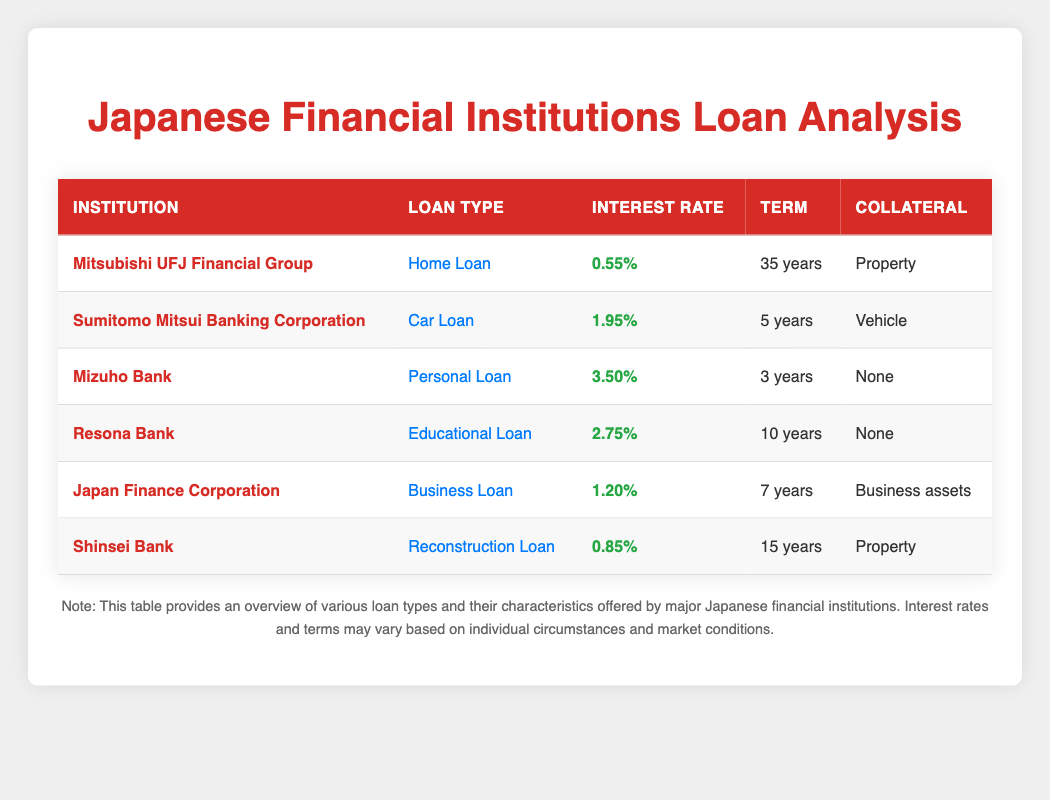What is the lowest interest rate among the loans listed? By examining the table, we can see that the lowest interest rate is 0.55%, which is offered by Mitsubishi UFJ Financial Group for their Home Loan.
Answer: 0.55% Which financial institution offers a Personal Loan? Referring to the table, Mizuho Bank is listed as offering a Personal Loan.
Answer: Mizuho Bank Is the term of the car loan longer than the term of the home loan? The term for the Car Loan from Sumitomo Mitsui Banking Corporation is 5 years, while the Home Loan from Mitsubishi UFJ Financial Group has a term of 35 years. Since 5 years is less than 35 years, the statement is false.
Answer: No What type of loan has the highest interest rate? The table shows that the Personal Loan from Mizuho Bank has the highest interest rate at 3.50%.
Answer: Personal Loan How many loans in the table offer a term of 10 years or more? Upon reviewing the table, the loans with a term of 10 years or more are the Home Loan (35 years), Educational Loan (10 years), and Reconstruction Loan (15 years). There are 3 loans that meet this criterion.
Answer: 3 Which loan requires collateral, and what type is it? By analyzing the collateral column in the table, both the Home Loan and Reconstruction Loan require collateral, specifically "Property". The Car Loan requires "Vehicle" collateral, and the Business Loan requires "Business assets". Therefore, there are several loans with required collateral.
Answer: Yes, Home Loan (Property), Reconstruction Loan (Property), Car Loan (Vehicle), Business Loan (Business assets) What is the average interest rate of the loans listed? The interest rates are 0.55%, 1.95%, 3.50%, 2.75%, 1.20%, and 0.85%. To find the average, we first convert the percentages to decimals: 0.0055, 0.0195, 0.0350, 0.0275, 0.0120, 0.0085. Next, we sum these values: 0.0055 + 0.0195 + 0.0350 + 0.0275 + 0.0120 + 0.0085 = 0.1080. Finally, dividing by 6 gives the average: 0.1080 / 6 = 0.0180, or 1.80%.
Answer: 1.80% Which institution offers loans without requiring collateral? The table shows that Mizuho Bank for Personal Loan and Resona Bank for Educational Loan do not require any collateral at all.
Answer: Mizuho Bank, Resona Bank Is there a loan for which the term is exactly 7 years? Looking at the table, only the Japan Finance Corporation offers a Business Loan with a term of 7 years.
Answer: Yes, Business Loan (Japan Finance Corporation) 